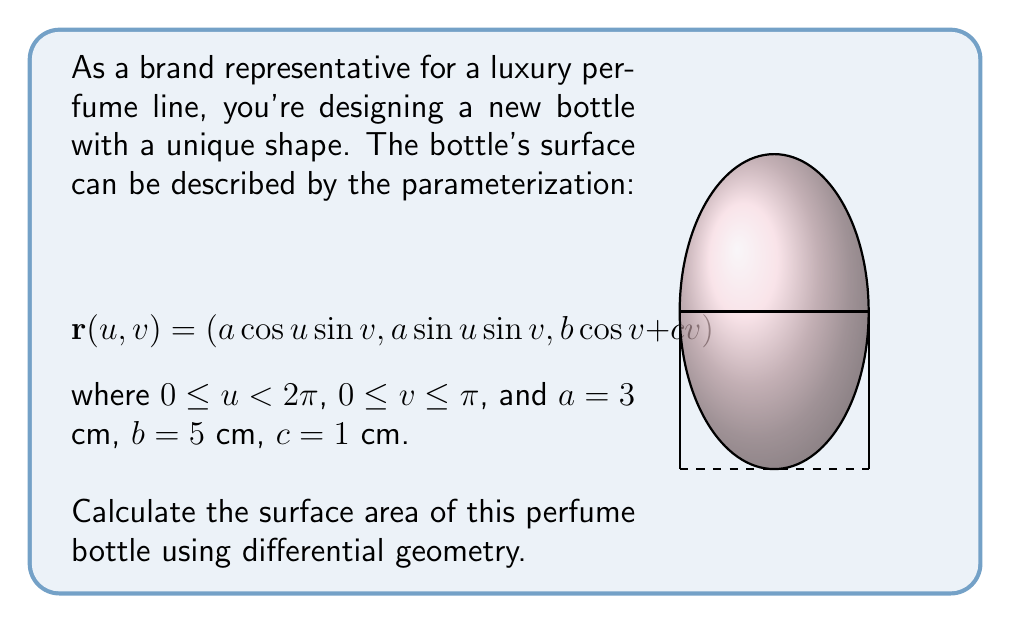Can you solve this math problem? To calculate the surface area using differential geometry, we need to follow these steps:

1) First, we need to calculate the partial derivatives of $\mathbf{r}$ with respect to $u$ and $v$:

   $$\mathbf{r}_u = (-a\sin u \sin v, a\cos u \sin v, 0)$$
   $$\mathbf{r}_v = (a\cos u \cos v, a\sin u \cos v, -b\sin v + c)$$

2) Next, we compute the cross product $\mathbf{r}_u \times \mathbf{r}_v$:

   $$\mathbf{r}_u \times \mathbf{r}_v = (a^2\cos u \sin^2 v + ab\sin u \sin^2 v - ac\sin u \sin v,$$
   $$a^2\sin u \sin^2 v - ab\cos u \sin^2 v + ac\cos u \sin v,$$
   $$a^2\sin v \cos v)$$

3) The magnitude of this cross product gives us the surface element:

   $$\|\mathbf{r}_u \times \mathbf{r}_v\| = \sqrt{(a\sin v)^2((a\sin v)^2 + (b\sin v - c)^2)}$$

4) The surface area is then given by the double integral:

   $$A = \int_0^{2\pi} \int_0^{\pi} \|\mathbf{r}_u \times \mathbf{r}_v\| \, dv \, du$$

5) Substituting the values $a=3$, $b=5$, and $c=1$:

   $$A = \int_0^{2\pi} \int_0^{\pi} \sqrt{(3\sin v)^2((3\sin v)^2 + (5\sin v - 1)^2)} \, dv \, du$$

6) The integral with respect to $u$ simply multiplies the result by $2\pi$, so we have:

   $$A = 2\pi \int_0^{\pi} \sqrt{(3\sin v)^2((3\sin v)^2 + (5\sin v - 1)^2)} \, dv$$

7) This integral doesn't have a simple closed form and needs to be evaluated numerically. Using numerical integration methods, we get:

   $$A \approx 213.8 \text{ cm}^2$$
Answer: $213.8 \text{ cm}^2$ 